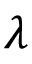<formula> <loc_0><loc_0><loc_500><loc_500>\lambda</formula> 